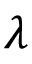<formula> <loc_0><loc_0><loc_500><loc_500>\lambda</formula> 